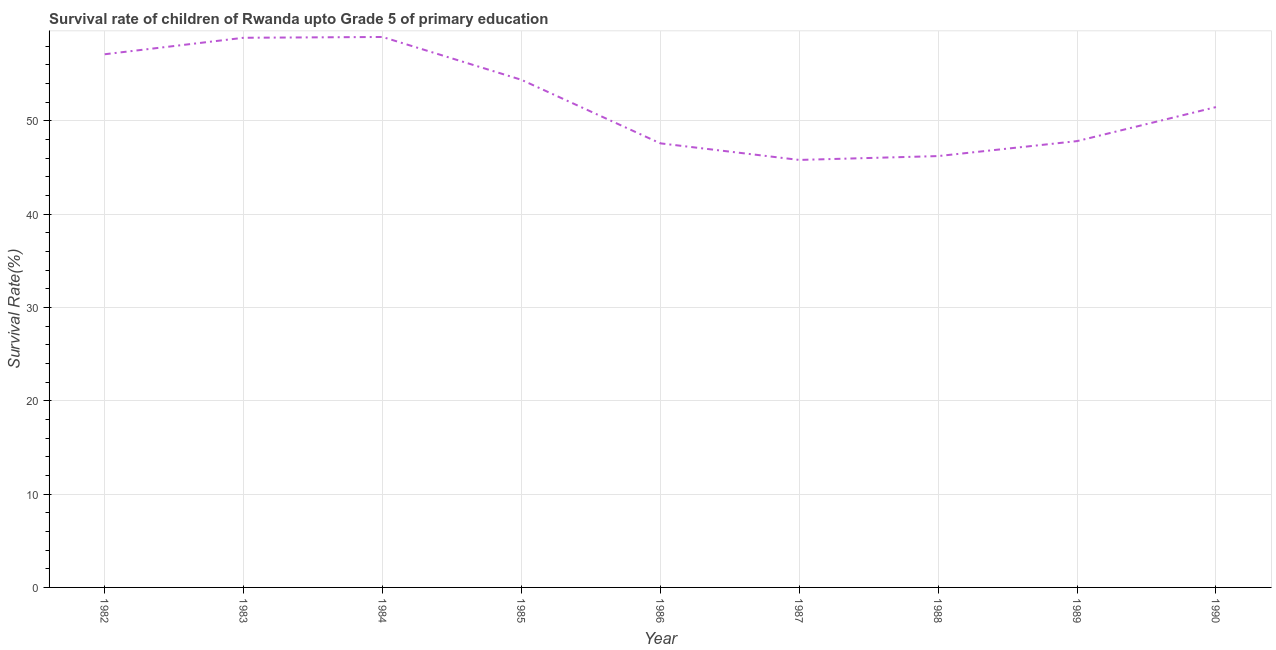What is the survival rate in 1986?
Keep it short and to the point. 47.59. Across all years, what is the maximum survival rate?
Your answer should be compact. 58.99. Across all years, what is the minimum survival rate?
Offer a terse response. 45.81. What is the sum of the survival rate?
Offer a very short reply. 468.35. What is the difference between the survival rate in 1982 and 1985?
Make the answer very short. 2.74. What is the average survival rate per year?
Your response must be concise. 52.04. What is the median survival rate?
Your response must be concise. 51.47. Do a majority of the years between 1990 and 1987 (inclusive) have survival rate greater than 4 %?
Your answer should be compact. Yes. What is the ratio of the survival rate in 1983 to that in 1985?
Make the answer very short. 1.08. What is the difference between the highest and the second highest survival rate?
Give a very brief answer. 0.09. Is the sum of the survival rate in 1982 and 1990 greater than the maximum survival rate across all years?
Your answer should be compact. Yes. What is the difference between the highest and the lowest survival rate?
Provide a short and direct response. 13.18. In how many years, is the survival rate greater than the average survival rate taken over all years?
Ensure brevity in your answer.  4. Does the survival rate monotonically increase over the years?
Provide a short and direct response. No. Does the graph contain any zero values?
Keep it short and to the point. No. Does the graph contain grids?
Your response must be concise. Yes. What is the title of the graph?
Provide a succinct answer. Survival rate of children of Rwanda upto Grade 5 of primary education. What is the label or title of the X-axis?
Provide a succinct answer. Year. What is the label or title of the Y-axis?
Your response must be concise. Survival Rate(%). What is the Survival Rate(%) of 1982?
Make the answer very short. 57.14. What is the Survival Rate(%) in 1983?
Keep it short and to the point. 58.9. What is the Survival Rate(%) of 1984?
Give a very brief answer. 58.99. What is the Survival Rate(%) of 1985?
Provide a short and direct response. 54.4. What is the Survival Rate(%) of 1986?
Keep it short and to the point. 47.59. What is the Survival Rate(%) of 1987?
Your response must be concise. 45.81. What is the Survival Rate(%) of 1988?
Your response must be concise. 46.22. What is the Survival Rate(%) of 1989?
Your response must be concise. 47.83. What is the Survival Rate(%) in 1990?
Provide a succinct answer. 51.47. What is the difference between the Survival Rate(%) in 1982 and 1983?
Your answer should be very brief. -1.77. What is the difference between the Survival Rate(%) in 1982 and 1984?
Provide a succinct answer. -1.85. What is the difference between the Survival Rate(%) in 1982 and 1985?
Your answer should be compact. 2.74. What is the difference between the Survival Rate(%) in 1982 and 1986?
Ensure brevity in your answer.  9.55. What is the difference between the Survival Rate(%) in 1982 and 1987?
Your answer should be compact. 11.32. What is the difference between the Survival Rate(%) in 1982 and 1988?
Ensure brevity in your answer.  10.91. What is the difference between the Survival Rate(%) in 1982 and 1989?
Provide a succinct answer. 9.31. What is the difference between the Survival Rate(%) in 1982 and 1990?
Ensure brevity in your answer.  5.66. What is the difference between the Survival Rate(%) in 1983 and 1984?
Keep it short and to the point. -0.09. What is the difference between the Survival Rate(%) in 1983 and 1985?
Ensure brevity in your answer.  4.5. What is the difference between the Survival Rate(%) in 1983 and 1986?
Your answer should be very brief. 11.31. What is the difference between the Survival Rate(%) in 1983 and 1987?
Provide a succinct answer. 13.09. What is the difference between the Survival Rate(%) in 1983 and 1988?
Ensure brevity in your answer.  12.68. What is the difference between the Survival Rate(%) in 1983 and 1989?
Ensure brevity in your answer.  11.08. What is the difference between the Survival Rate(%) in 1983 and 1990?
Your response must be concise. 7.43. What is the difference between the Survival Rate(%) in 1984 and 1985?
Make the answer very short. 4.59. What is the difference between the Survival Rate(%) in 1984 and 1986?
Keep it short and to the point. 11.4. What is the difference between the Survival Rate(%) in 1984 and 1987?
Keep it short and to the point. 13.18. What is the difference between the Survival Rate(%) in 1984 and 1988?
Your response must be concise. 12.76. What is the difference between the Survival Rate(%) in 1984 and 1989?
Provide a short and direct response. 11.16. What is the difference between the Survival Rate(%) in 1984 and 1990?
Keep it short and to the point. 7.51. What is the difference between the Survival Rate(%) in 1985 and 1986?
Make the answer very short. 6.81. What is the difference between the Survival Rate(%) in 1985 and 1987?
Provide a short and direct response. 8.59. What is the difference between the Survival Rate(%) in 1985 and 1988?
Your response must be concise. 8.17. What is the difference between the Survival Rate(%) in 1985 and 1989?
Provide a short and direct response. 6.57. What is the difference between the Survival Rate(%) in 1985 and 1990?
Give a very brief answer. 2.92. What is the difference between the Survival Rate(%) in 1986 and 1987?
Your response must be concise. 1.78. What is the difference between the Survival Rate(%) in 1986 and 1988?
Ensure brevity in your answer.  1.37. What is the difference between the Survival Rate(%) in 1986 and 1989?
Give a very brief answer. -0.24. What is the difference between the Survival Rate(%) in 1986 and 1990?
Your answer should be very brief. -3.88. What is the difference between the Survival Rate(%) in 1987 and 1988?
Your answer should be very brief. -0.41. What is the difference between the Survival Rate(%) in 1987 and 1989?
Your answer should be compact. -2.02. What is the difference between the Survival Rate(%) in 1987 and 1990?
Keep it short and to the point. -5.66. What is the difference between the Survival Rate(%) in 1988 and 1989?
Your answer should be compact. -1.6. What is the difference between the Survival Rate(%) in 1988 and 1990?
Give a very brief answer. -5.25. What is the difference between the Survival Rate(%) in 1989 and 1990?
Your response must be concise. -3.65. What is the ratio of the Survival Rate(%) in 1982 to that in 1983?
Offer a very short reply. 0.97. What is the ratio of the Survival Rate(%) in 1982 to that in 1985?
Provide a short and direct response. 1.05. What is the ratio of the Survival Rate(%) in 1982 to that in 1986?
Offer a very short reply. 1.2. What is the ratio of the Survival Rate(%) in 1982 to that in 1987?
Provide a short and direct response. 1.25. What is the ratio of the Survival Rate(%) in 1982 to that in 1988?
Keep it short and to the point. 1.24. What is the ratio of the Survival Rate(%) in 1982 to that in 1989?
Provide a succinct answer. 1.2. What is the ratio of the Survival Rate(%) in 1982 to that in 1990?
Ensure brevity in your answer.  1.11. What is the ratio of the Survival Rate(%) in 1983 to that in 1985?
Provide a succinct answer. 1.08. What is the ratio of the Survival Rate(%) in 1983 to that in 1986?
Ensure brevity in your answer.  1.24. What is the ratio of the Survival Rate(%) in 1983 to that in 1987?
Ensure brevity in your answer.  1.29. What is the ratio of the Survival Rate(%) in 1983 to that in 1988?
Offer a terse response. 1.27. What is the ratio of the Survival Rate(%) in 1983 to that in 1989?
Your response must be concise. 1.23. What is the ratio of the Survival Rate(%) in 1983 to that in 1990?
Your answer should be compact. 1.14. What is the ratio of the Survival Rate(%) in 1984 to that in 1985?
Offer a very short reply. 1.08. What is the ratio of the Survival Rate(%) in 1984 to that in 1986?
Ensure brevity in your answer.  1.24. What is the ratio of the Survival Rate(%) in 1984 to that in 1987?
Ensure brevity in your answer.  1.29. What is the ratio of the Survival Rate(%) in 1984 to that in 1988?
Give a very brief answer. 1.28. What is the ratio of the Survival Rate(%) in 1984 to that in 1989?
Offer a terse response. 1.23. What is the ratio of the Survival Rate(%) in 1984 to that in 1990?
Provide a short and direct response. 1.15. What is the ratio of the Survival Rate(%) in 1985 to that in 1986?
Give a very brief answer. 1.14. What is the ratio of the Survival Rate(%) in 1985 to that in 1987?
Ensure brevity in your answer.  1.19. What is the ratio of the Survival Rate(%) in 1985 to that in 1988?
Your answer should be compact. 1.18. What is the ratio of the Survival Rate(%) in 1985 to that in 1989?
Your answer should be very brief. 1.14. What is the ratio of the Survival Rate(%) in 1985 to that in 1990?
Ensure brevity in your answer.  1.06. What is the ratio of the Survival Rate(%) in 1986 to that in 1987?
Ensure brevity in your answer.  1.04. What is the ratio of the Survival Rate(%) in 1986 to that in 1988?
Give a very brief answer. 1.03. What is the ratio of the Survival Rate(%) in 1986 to that in 1990?
Make the answer very short. 0.93. What is the ratio of the Survival Rate(%) in 1987 to that in 1988?
Offer a terse response. 0.99. What is the ratio of the Survival Rate(%) in 1987 to that in 1989?
Your answer should be very brief. 0.96. What is the ratio of the Survival Rate(%) in 1987 to that in 1990?
Give a very brief answer. 0.89. What is the ratio of the Survival Rate(%) in 1988 to that in 1989?
Provide a succinct answer. 0.97. What is the ratio of the Survival Rate(%) in 1988 to that in 1990?
Your answer should be very brief. 0.9. What is the ratio of the Survival Rate(%) in 1989 to that in 1990?
Keep it short and to the point. 0.93. 